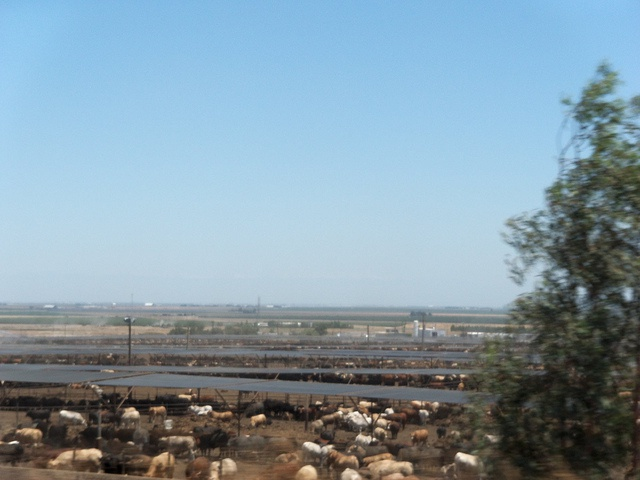Describe the objects in this image and their specific colors. I can see cow in lightblue, black, gray, and maroon tones, cow in lightblue, tan, gray, and maroon tones, cow in lightblue, black, and gray tones, cow in lightblue, black, and gray tones, and cow in lightblue, tan, and gray tones in this image. 